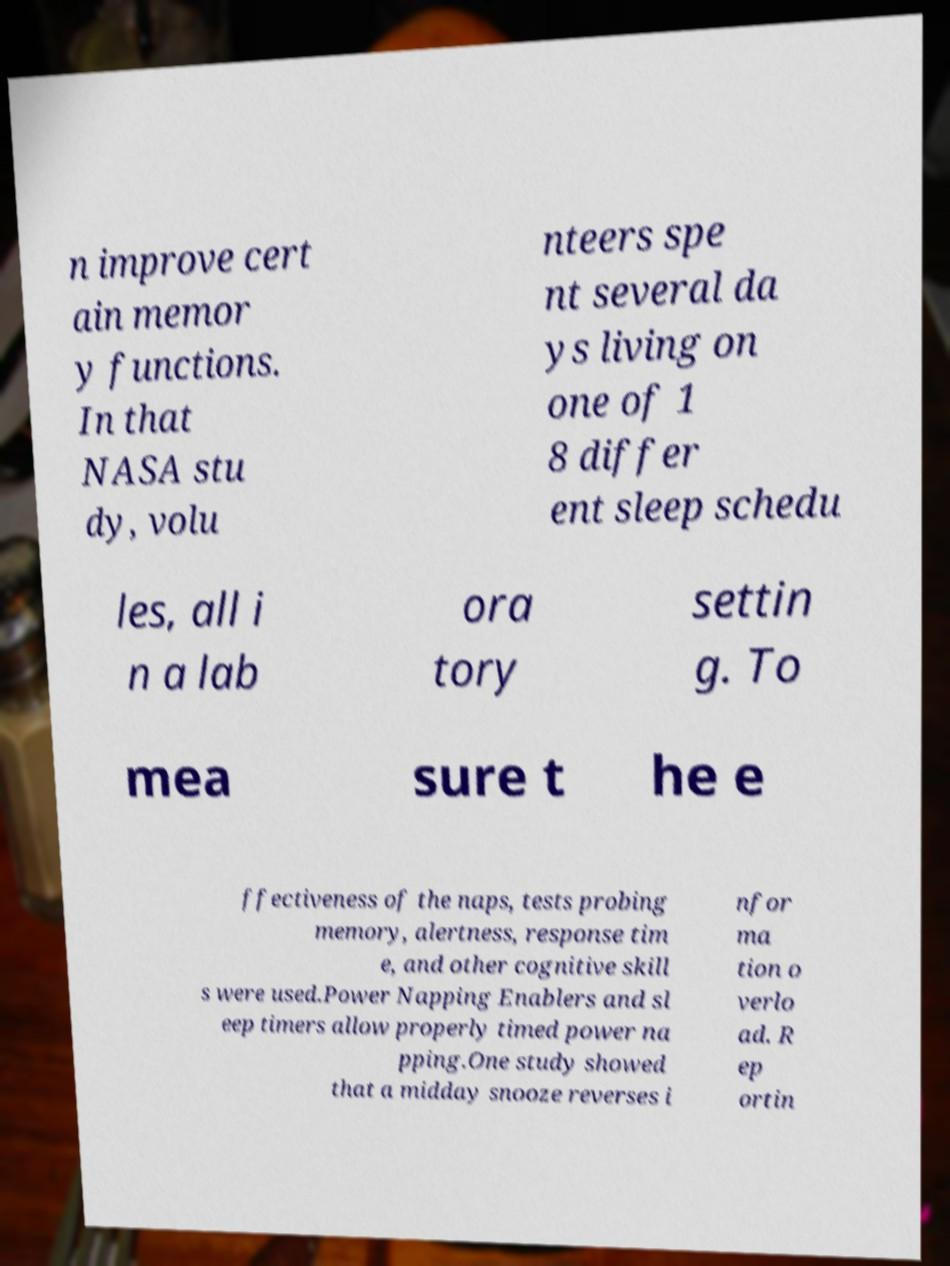There's text embedded in this image that I need extracted. Can you transcribe it verbatim? n improve cert ain memor y functions. In that NASA stu dy, volu nteers spe nt several da ys living on one of 1 8 differ ent sleep schedu les, all i n a lab ora tory settin g. To mea sure t he e ffectiveness of the naps, tests probing memory, alertness, response tim e, and other cognitive skill s were used.Power Napping Enablers and sl eep timers allow properly timed power na pping.One study showed that a midday snooze reverses i nfor ma tion o verlo ad. R ep ortin 